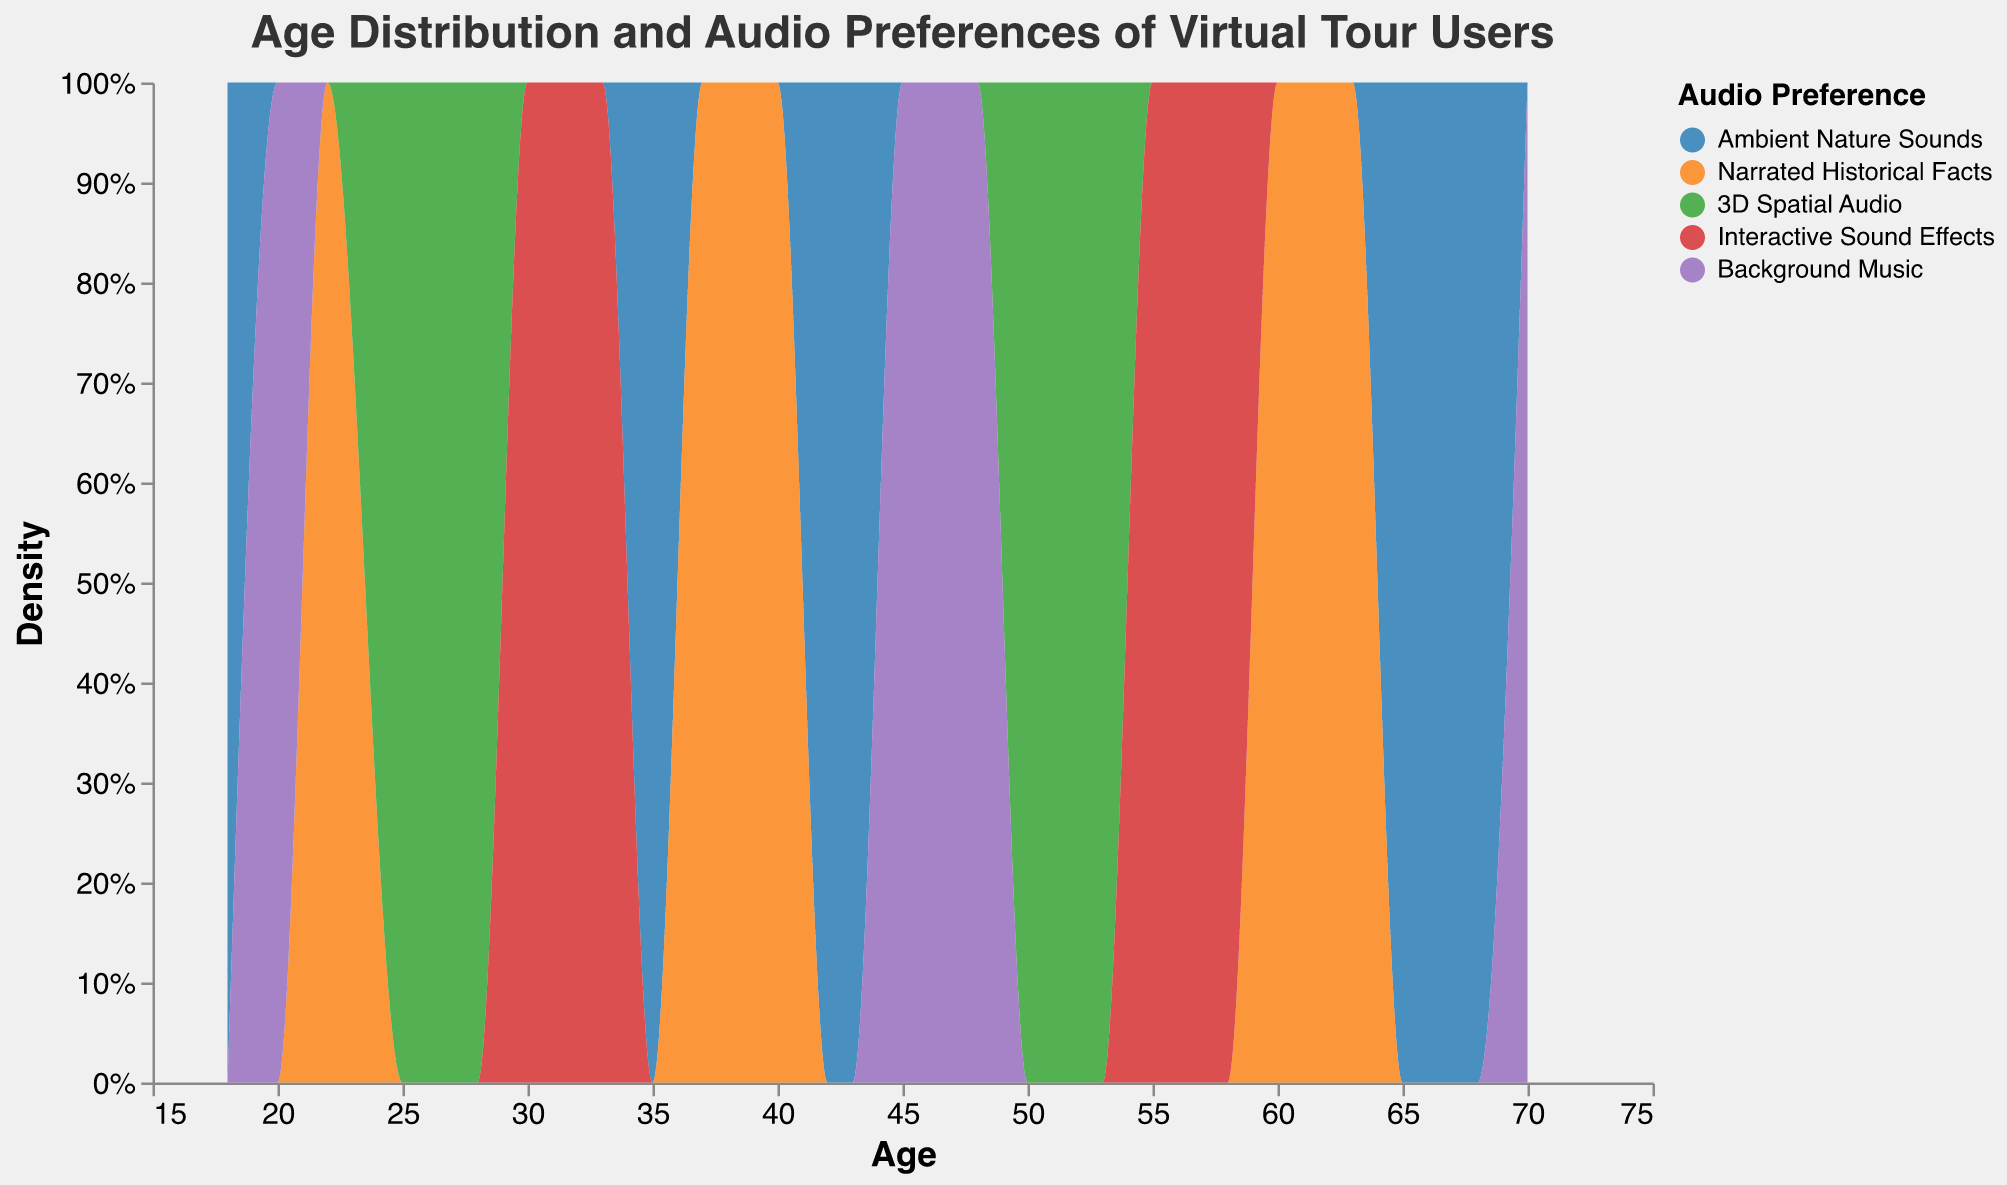What's the title of the figure? The title is displayed at the top of the figure in a large font. It provides a brief description of what the figure represents.
Answer: Age Distribution and Audio Preferences of Virtual Tour Users What are the age ranges covered in the x-axis? The x-axis labels age, starting from 15 and ranging to 75, as indicated by the scale domain.
Answer: 15 to 75 Which audio preference has the highest density among users aged 30 to 40? By looking at the section of the plot between ages 30 to 40, the area for "Narrated Historical Facts" has the highest peak.
Answer: Narrated Historical Facts How many audio preferences are represented in the plot? The legend on the right-hand side of the plot lists all the audio preferences represented in the figure.
Answer: 5 Which audio preference is most popular among users aged 60 and above? By examining the density distribution for ages 60 and above, "Narrated Historical Facts" has the highest peaks.
Answer: Narrated Historical Facts What is the color representation for '3D Spatial Audio' in the plot? The legend specifies the color associated with each audio preference. '3D Spatial Audio' is marked in green.
Answer: Green At what age range does 'Background Music' show the highest density? The plotted density area for 'Background Music' reaches its peak between the ages of 45-50.
Answer: 45-50 Are there any age groups where "Interactive Sound Effects" has a significantly lower density compared to others? Reviewing the plot, "Interactive Sound Effects" generally show a lower density across all age ranges except for notable densities around ages 30 and 55.
Answer: Generally lower Which audio preference peaks twice within the age range shown in the plot? By analyzing the density peaks for each audio preference, "Ambient Nature Sounds" peaks around ages 35 and 65.
Answer: Ambient Nature Sounds Do ambient nature sounds have more density spikes in older or younger age groups? Evaluating the density plot, "Ambient Nature Sounds" has pronounced spikes predominantly in older age groups (around 65).
Answer: Older age groups 